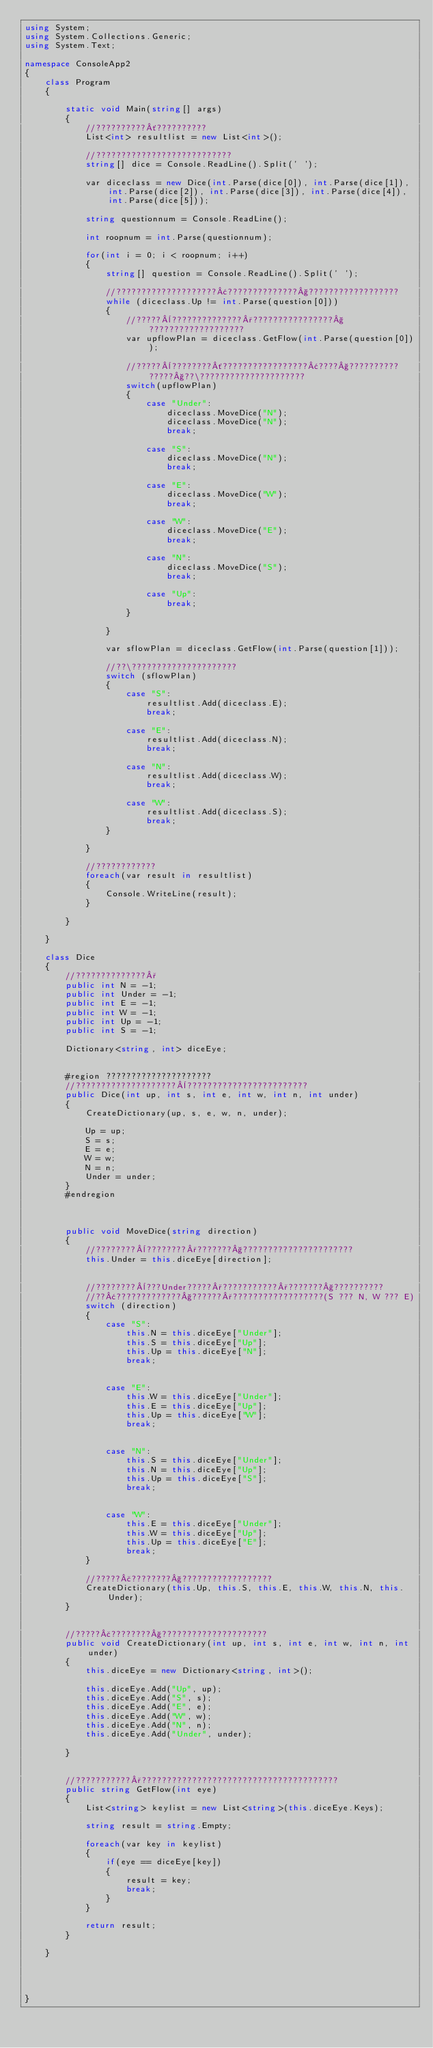Convert code to text. <code><loc_0><loc_0><loc_500><loc_500><_C#_>using System;
using System.Collections.Generic;
using System.Text;

namespace ConsoleApp2
{
    class Program
    {

        static void Main(string[] args)
        {
            //??????????´??????????
            List<int> resultlist = new List<int>();

            //???????????????????????????
            string[] dice = Console.ReadLine().Split(' ');

            var diceclass = new Dice(int.Parse(dice[0]), int.Parse(dice[1]), int.Parse(dice[2]), int.Parse(dice[3]), int.Parse(dice[4]), int.Parse(dice[5]));

            string questionnum = Console.ReadLine();

            int roopnum = int.Parse(questionnum);

            for(int i = 0; i < roopnum; i++)
            {
                string[] question = Console.ReadLine().Split(' ');

                //????????????????????¢??????????????§??????????????????
                while (diceclass.Up != int.Parse(question[0]))
                {
                    //?????¨??????????????°????????????????§???????????????????
                    var upflowPlan = diceclass.GetFlow(int.Parse(question[0]));
                    
                    //?????¨????????´?????????????????¢????§?????????? ?????§??\?????????????????????
                    switch(upflowPlan)
                    {
                        case "Under":
                            diceclass.MoveDice("N");
                            diceclass.MoveDice("N");
                            break;

                        case "S":
                            diceclass.MoveDice("N");
                            break;

                        case "E":
                            diceclass.MoveDice("W");
                            break;

                        case "W":
                            diceclass.MoveDice("E");
                            break;

                        case "N":
                            diceclass.MoveDice("S");
                            break;

                        case "Up":
                            break;
                    }

                }

                var sflowPlan = diceclass.GetFlow(int.Parse(question[1]));

                //??\?????????????????????
                switch (sflowPlan)
                {
                    case "S":
                        resultlist.Add(diceclass.E);
                        break;

                    case "E":
                        resultlist.Add(diceclass.N);
                        break;

                    case "N":
                        resultlist.Add(diceclass.W);
                        break;

                    case "W":
                        resultlist.Add(diceclass.S);
                        break;                        
                }

            }

            //????????????
            foreach(var result in resultlist)
            {
                Console.WriteLine(result);
            }

        }

    }

    class Dice
    {
        //??????????????°
        public int N = -1;
        public int Under = -1;
        public int E = -1;
        public int W = -1;
        public int Up = -1;
        public int S = -1;

        Dictionary<string, int> diceEye;


        #region ?????????????????????
        //????????????????????¨????????????????????????
        public Dice(int up, int s, int e, int w, int n, int under)
        {
            CreateDictionary(up, s, e, w, n, under);

            Up = up;
            S = s;
            E = e;
            W = w;
            N = n;
            Under = under;
        }
        #endregion



        public void MoveDice(string direction)
        {
            //????????¨????????°???????§??????????????????????
            this.Under = this.diceEye[direction];


            //????????¨???Under?????°???????????°???????§??????????
            //??¢?????????????§??????°??????????????????(S ??? N, W ??? E)
            switch (direction)
            {
                case "S":
                    this.N = this.diceEye["Under"];
                    this.S = this.diceEye["Up"];
                    this.Up = this.diceEye["N"];
                    break;


                case "E":
                    this.W = this.diceEye["Under"];
                    this.E = this.diceEye["Up"];
                    this.Up = this.diceEye["W"];
                    break;


                case "N":
                    this.S = this.diceEye["Under"];
                    this.N = this.diceEye["Up"];
                    this.Up = this.diceEye["S"];
                    break;


                case "W":
                    this.E = this.diceEye["Under"];
                    this.W = this.diceEye["Up"];
                    this.Up = this.diceEye["E"];
                    break;
            }

            //?????£????????§??????????????????
            CreateDictionary(this.Up, this.S, this.E, this.W, this.N, this.Under);
        }


        //?????£????????§?????????????????????
        public void CreateDictionary(int up, int s, int e, int w, int n, int under)
        {
            this.diceEye = new Dictionary<string, int>();

            this.diceEye.Add("Up", up);
            this.diceEye.Add("S", s);
            this.diceEye.Add("E", e);
            this.diceEye.Add("W", w);
            this.diceEye.Add("N", n);
            this.diceEye.Add("Under", under);

        }


        //???????????°???????????????????????????????????????
        public string GetFlow(int eye)
        {
            List<string> keylist = new List<string>(this.diceEye.Keys);

            string result = string.Empty;

            foreach(var key in keylist)
            {
                if(eye == diceEye[key])
                {
                    result = key;
                    break;
                }
            }

            return result;
        }

    }




}</code> 